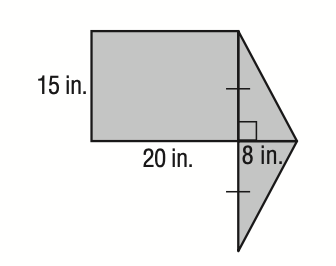Question: Find the area of the shaded figure in square inches. Round to the nearest tenth.
Choices:
A. 210
B. 300
C. 420
D. 840
Answer with the letter. Answer: C 